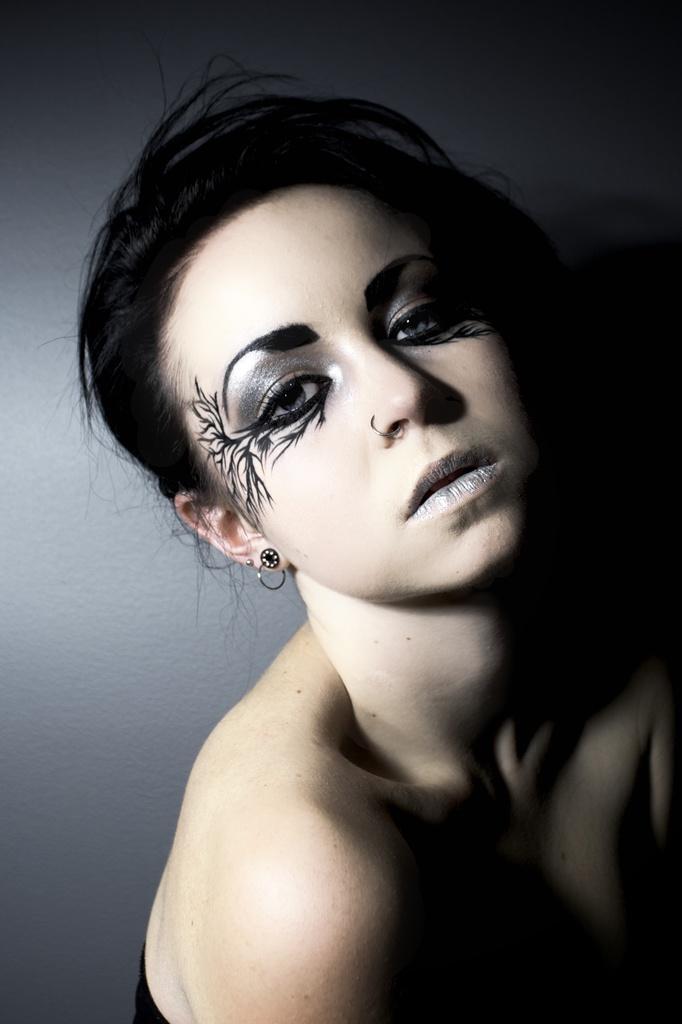Could you give a brief overview of what you see in this image? In this image there is a woman. 